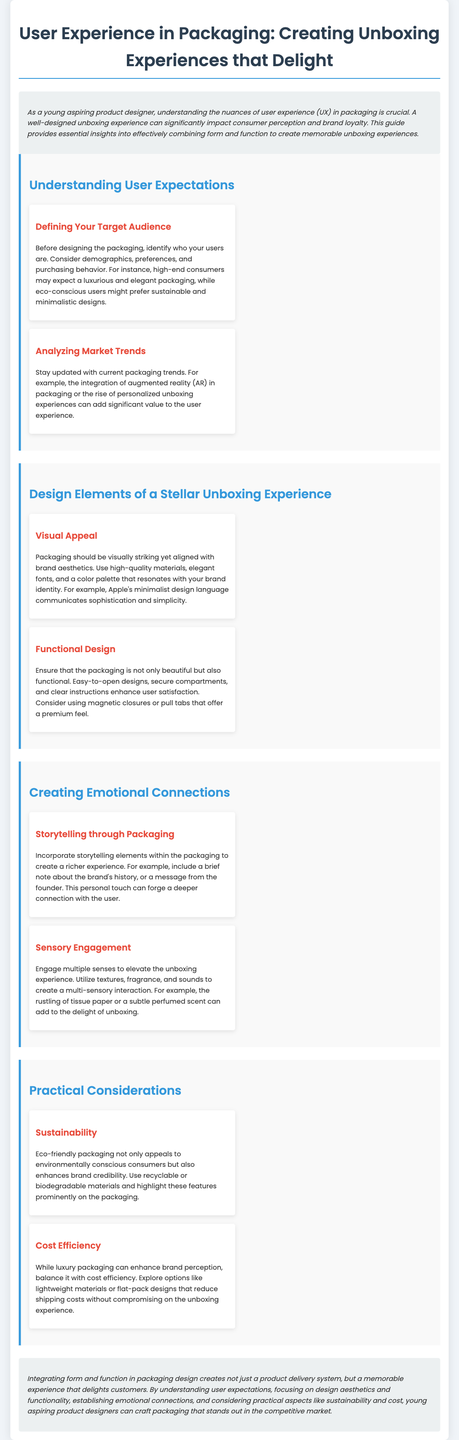What is the title of the document? The title of the document is stated in the header of the HTML, which outlines the main subject of the content.
Answer: User Experience in Packaging: Creating Unboxing Experiences that Delight Who should be identified before designing packaging? The document emphasizes understanding the audience when creating packaging to meet their expectations and preferences.
Answer: Target audience What color is primarily associated with the headings in the document? The document's styling indicates that the headings utilize a specific color for visual appeal, particularly for categorization.
Answer: #3498db What should packaging incorporate to create a deeper connection? The document suggests that adding narratives to packaging materials enriches the customer experience by making it more personal.
Answer: Storytelling What aspect of design does the section "Visual Appeal" focus on? In that section, the document discusses the importance of aesthetics and overall attractiveness in packaging design.
Answer: Aesthetics Which feature enhances the functionality of packaging? The document notes that practical elements within packaging can improve user satisfaction and ease of use.
Answer: Easy-to-open designs What does eco-friendly packaging appeal to? The statement in the document identifies a specific consumer group that is attracted to sustainable packaging options.
Answer: Environmentally conscious consumers What is mentioned as important besides luxury packaging? The document discusses the need to balance high-quality design with other aspects to ensure overall effectiveness in packaging.
Answer: Cost efficiency 